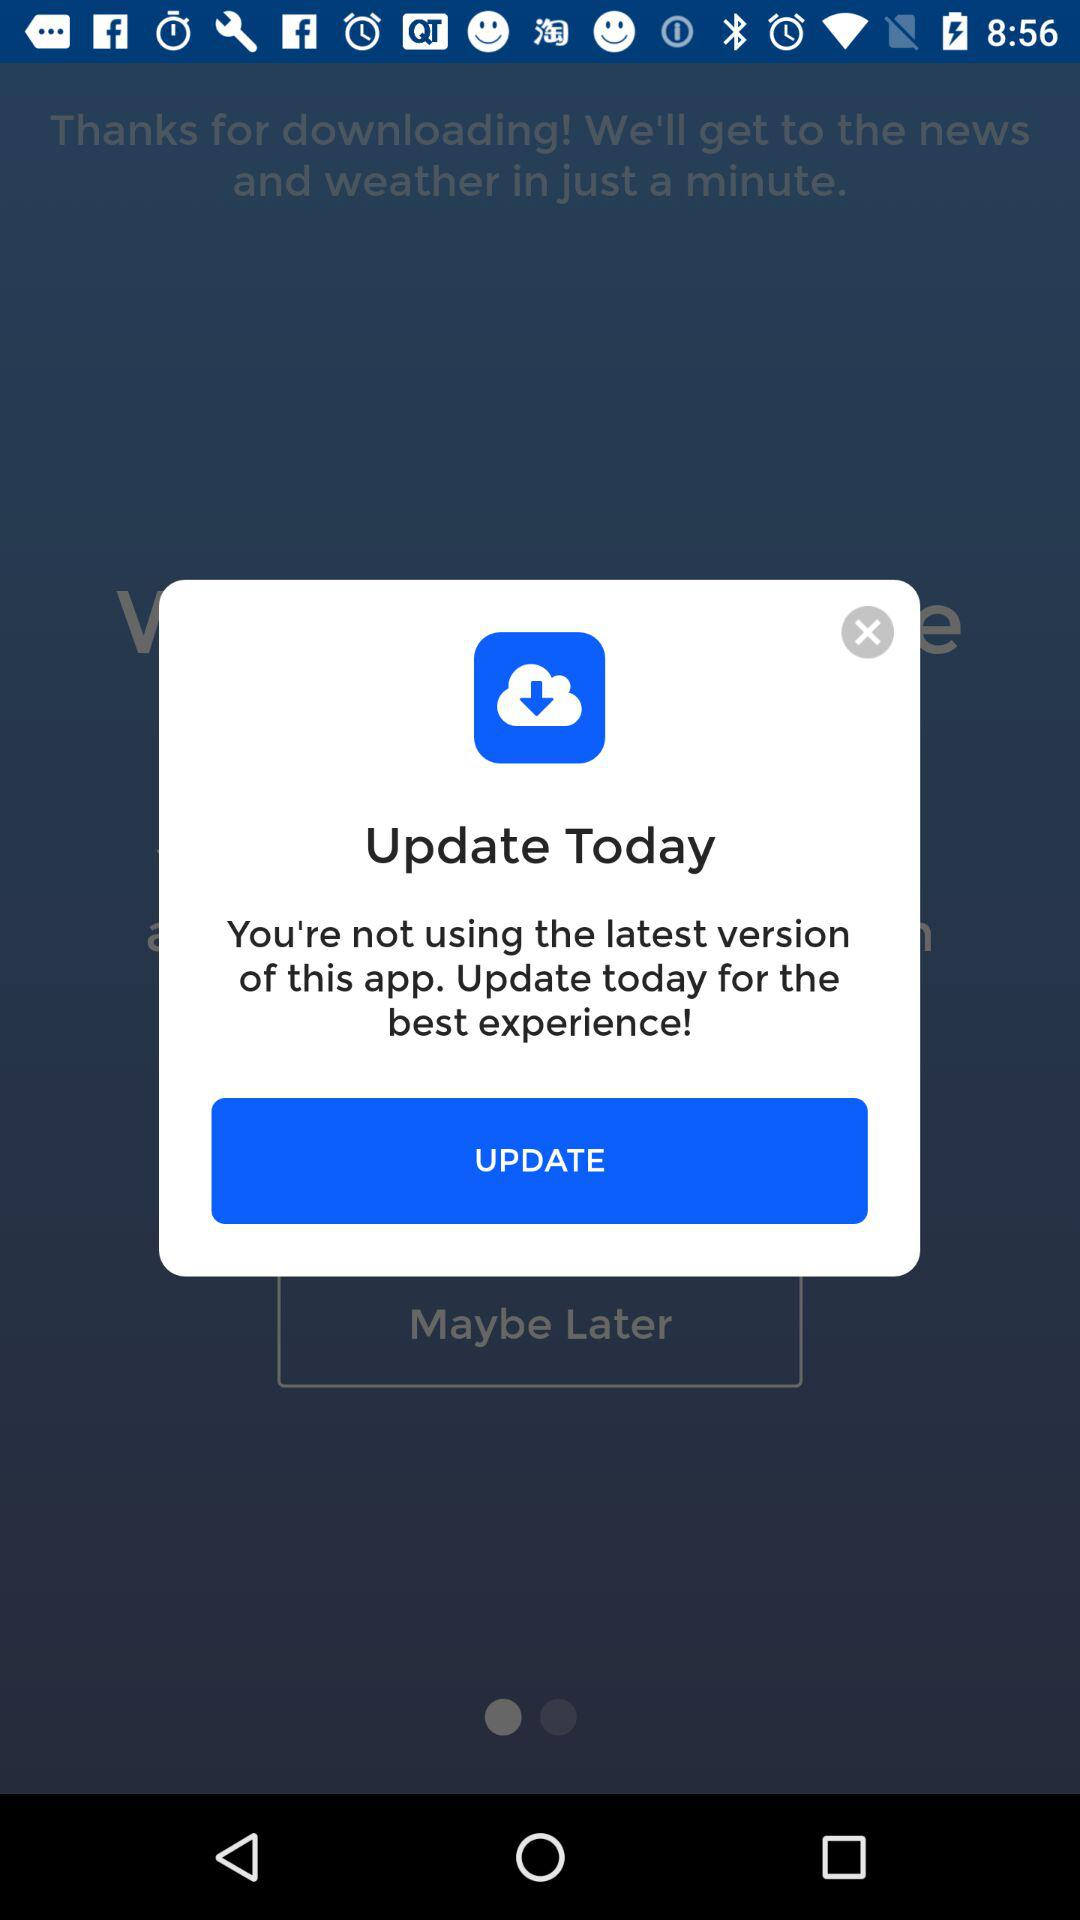Which version number of the application is being used now?
When the provided information is insufficient, respond with <no answer>. <no answer> 